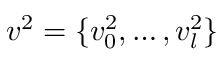<formula> <loc_0><loc_0><loc_500><loc_500>v ^ { 2 } = \{ v _ { 0 } ^ { 2 } , \dots , v _ { l } ^ { 2 } \}</formula> 